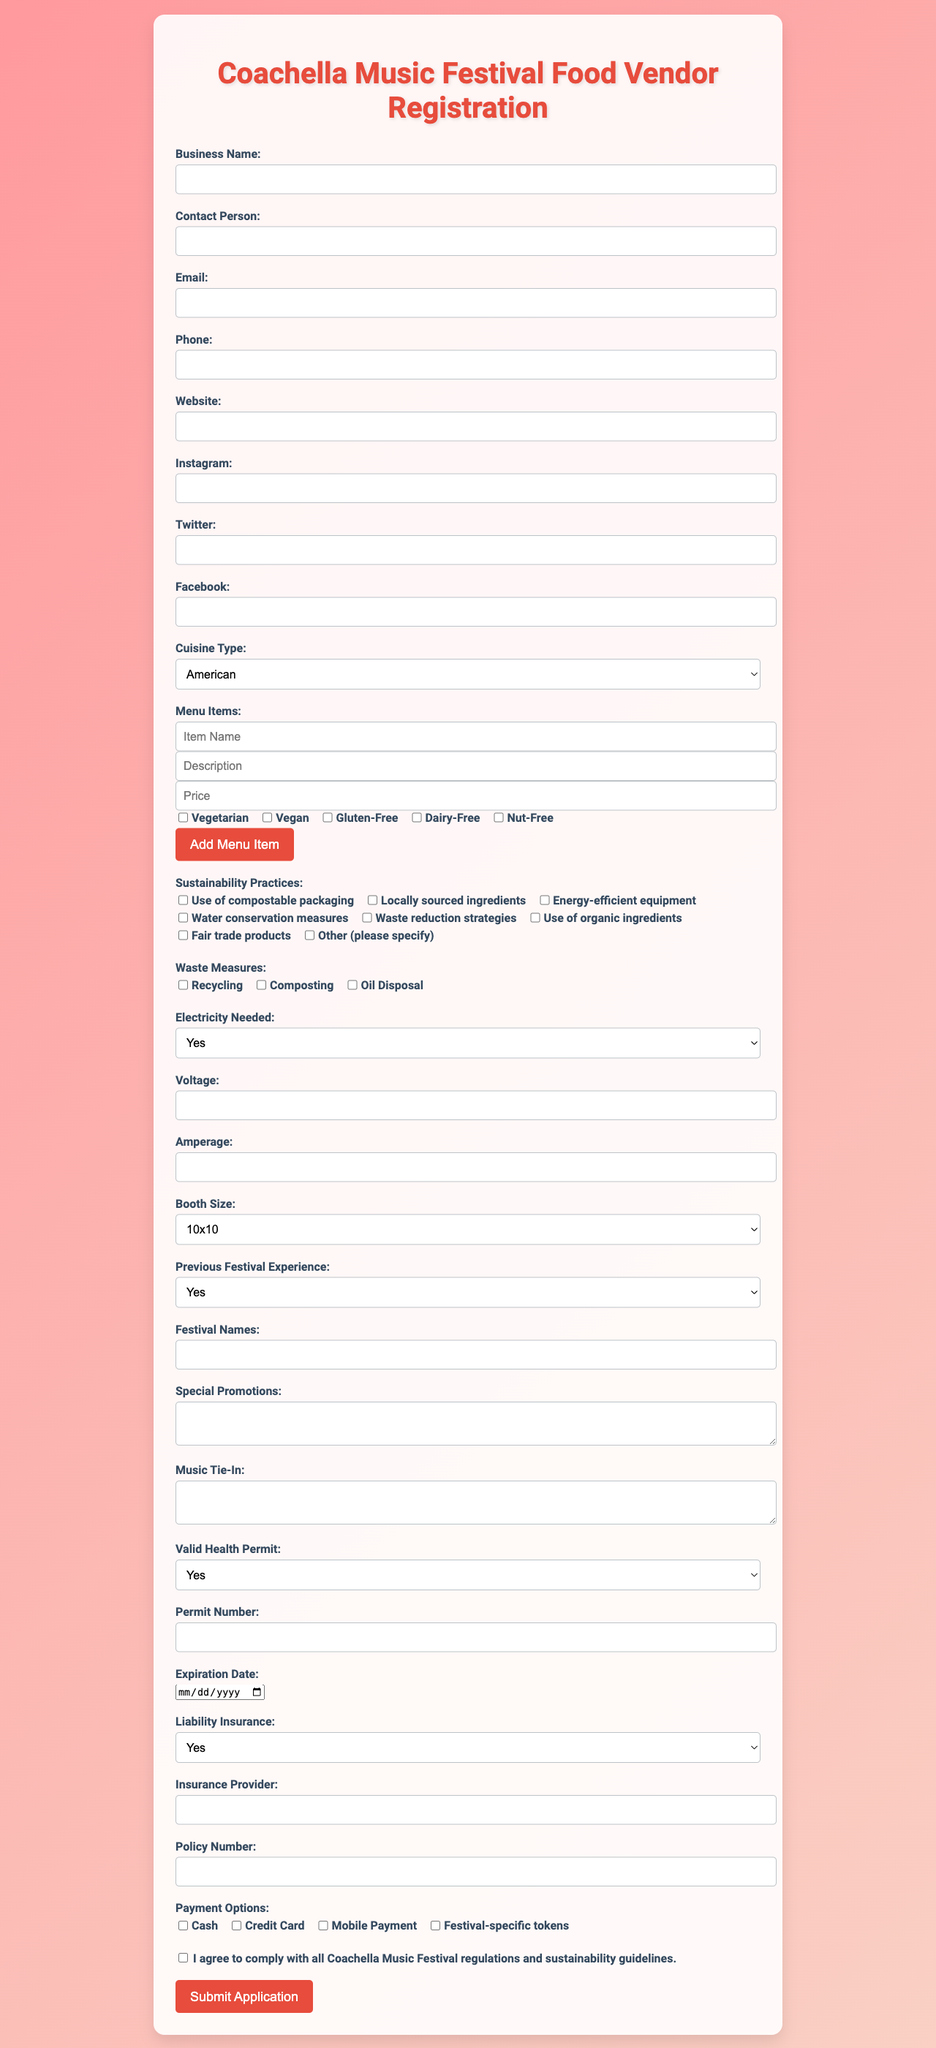What is the title of this document? The title is displayed prominently at the top of the document.
Answer: Coachella Music Festival Food Vendor Registration What types of cuisine can vendors select from? The available options for cuisine type are listed in a dropdown.
Answer: American, Mexican, Asian, Mediterranean, Vegan, Gluten-Free, Desserts, Beverages, Other What practices does the vendor need to follow for sustainability? The sustainability practices are listed as checkboxes for the vendor to select.
Answer: Use of compostable packaging What is the booth size option available for vendors? The booth sizes are provided in a dropdown menu from which the vendor can choose.
Answer: 10x10, 10x20, 20x20, Custom Does the vendor need a health permit? This is a yes or no question in the document that pertains to health regulations for food vendors.
Answer: Yes How many dietary restrictions can be selected for menu items? The dietary restrictions for menu items are available as checkboxes.
Answer: Five What should vendors submit to comply with regulations? Vendor compliance is indicated by an agreement that they agree to follow festival guidelines.
Answer: I agree to comply with all Coachella Music Festival regulations and sustainability guidelines What type of insurance must the vendor have? The document specifies that vendors need liability insurance.
Answer: Yes Is there a requirement for electricity? The form includes a question about the need for electricity.
Answer: Yes 